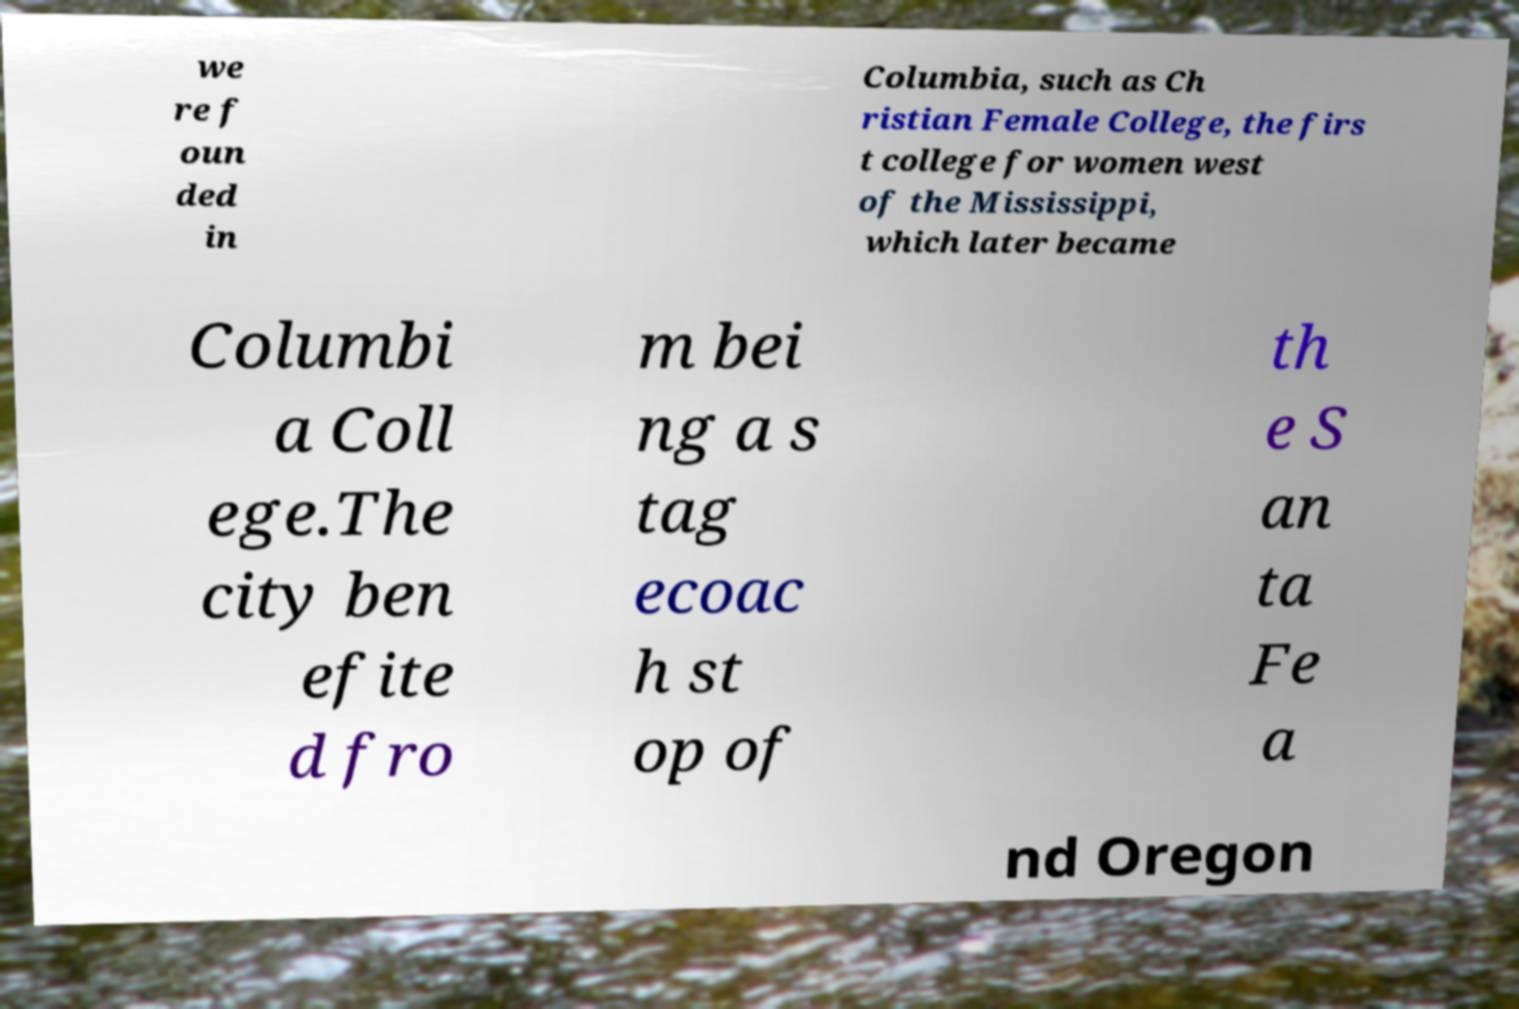Please read and relay the text visible in this image. What does it say? we re f oun ded in Columbia, such as Ch ristian Female College, the firs t college for women west of the Mississippi, which later became Columbi a Coll ege.The city ben efite d fro m bei ng a s tag ecoac h st op of th e S an ta Fe a nd Oregon 